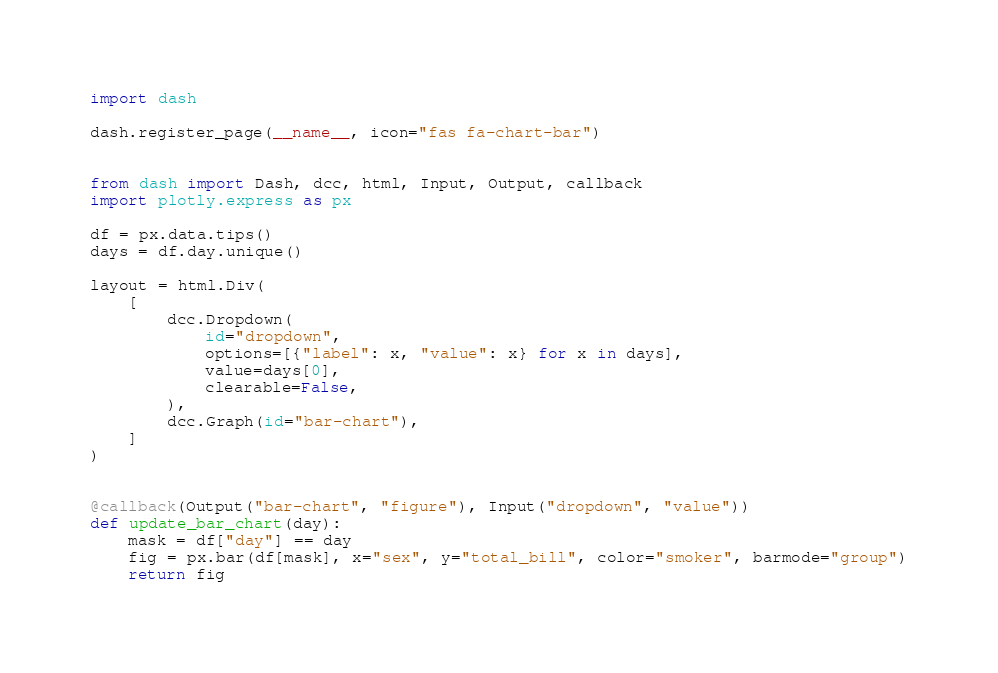Convert code to text. <code><loc_0><loc_0><loc_500><loc_500><_Python_>import dash

dash.register_page(__name__, icon="fas fa-chart-bar")


from dash import Dash, dcc, html, Input, Output, callback
import plotly.express as px

df = px.data.tips()
days = df.day.unique()

layout = html.Div(
    [
        dcc.Dropdown(
            id="dropdown",
            options=[{"label": x, "value": x} for x in days],
            value=days[0],
            clearable=False,
        ),
        dcc.Graph(id="bar-chart"),
    ]
)


@callback(Output("bar-chart", "figure"), Input("dropdown", "value"))
def update_bar_chart(day):
    mask = df["day"] == day
    fig = px.bar(df[mask], x="sex", y="total_bill", color="smoker", barmode="group")
    return fig
</code> 